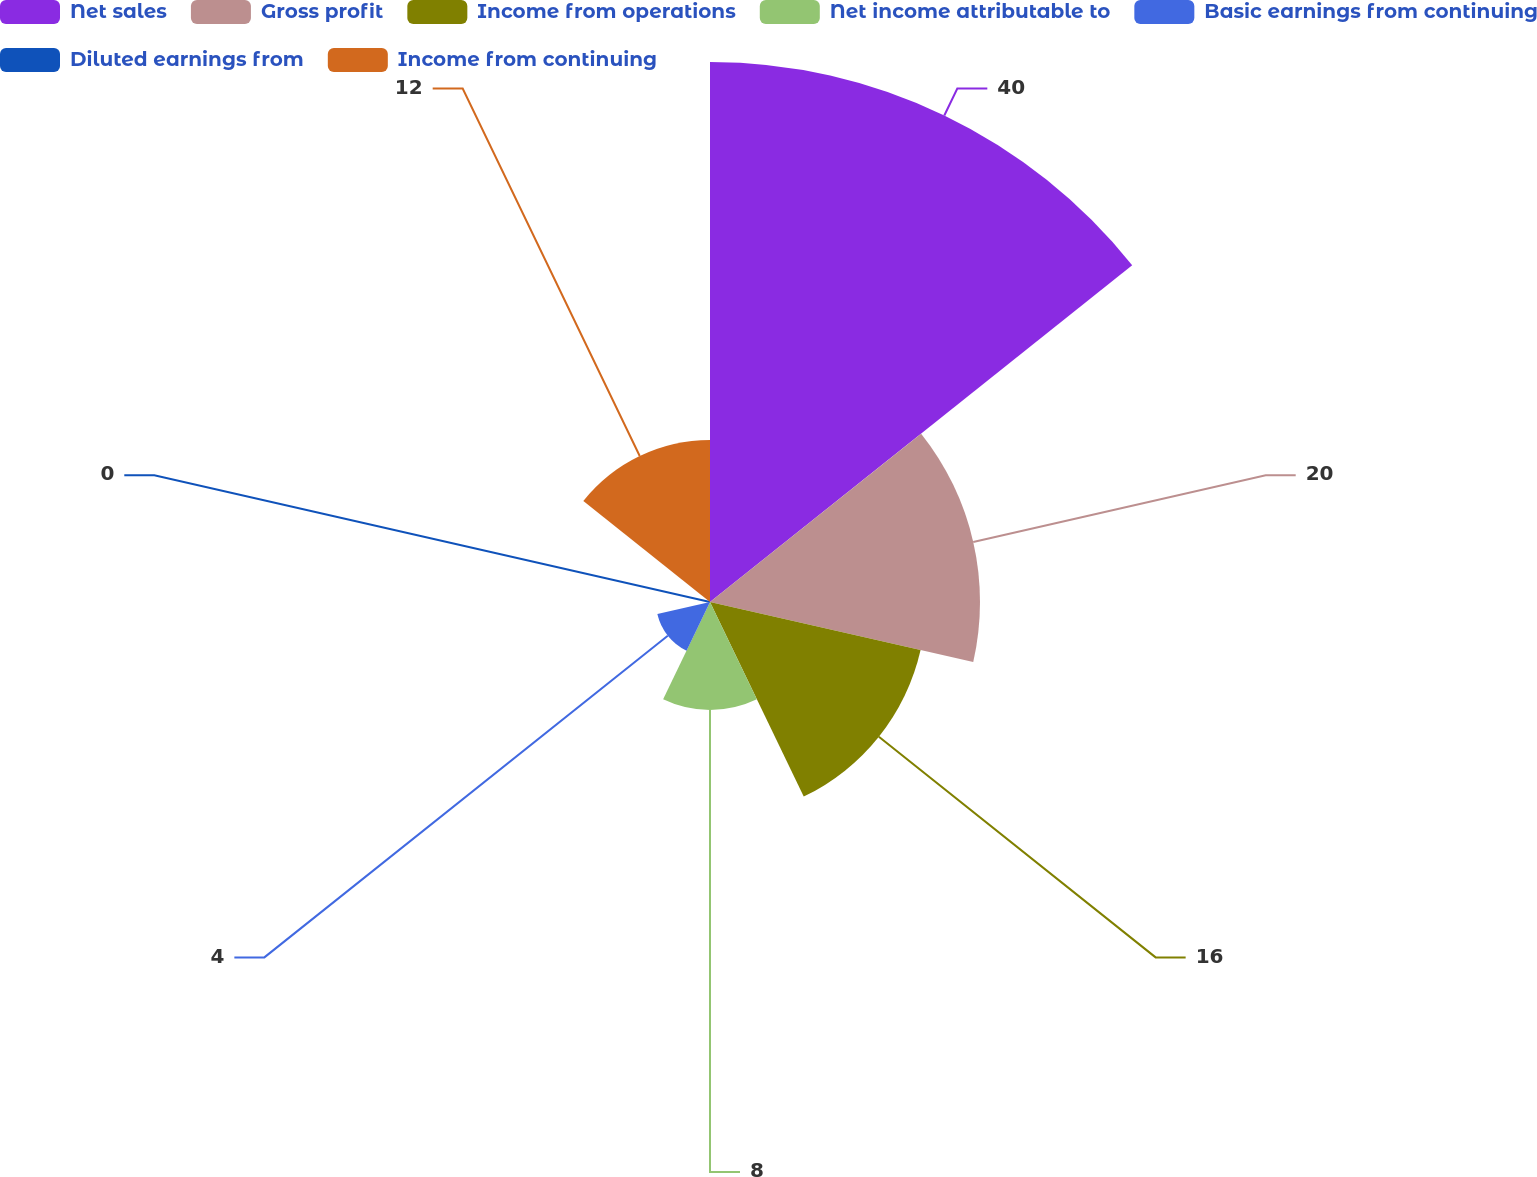<chart> <loc_0><loc_0><loc_500><loc_500><pie_chart><fcel>Net sales<fcel>Gross profit<fcel>Income from operations<fcel>Net income attributable to<fcel>Basic earnings from continuing<fcel>Diluted earnings from<fcel>Income from continuing<nl><fcel>40.0%<fcel>20.0%<fcel>16.0%<fcel>8.0%<fcel>4.0%<fcel>0.0%<fcel>12.0%<nl></chart> 